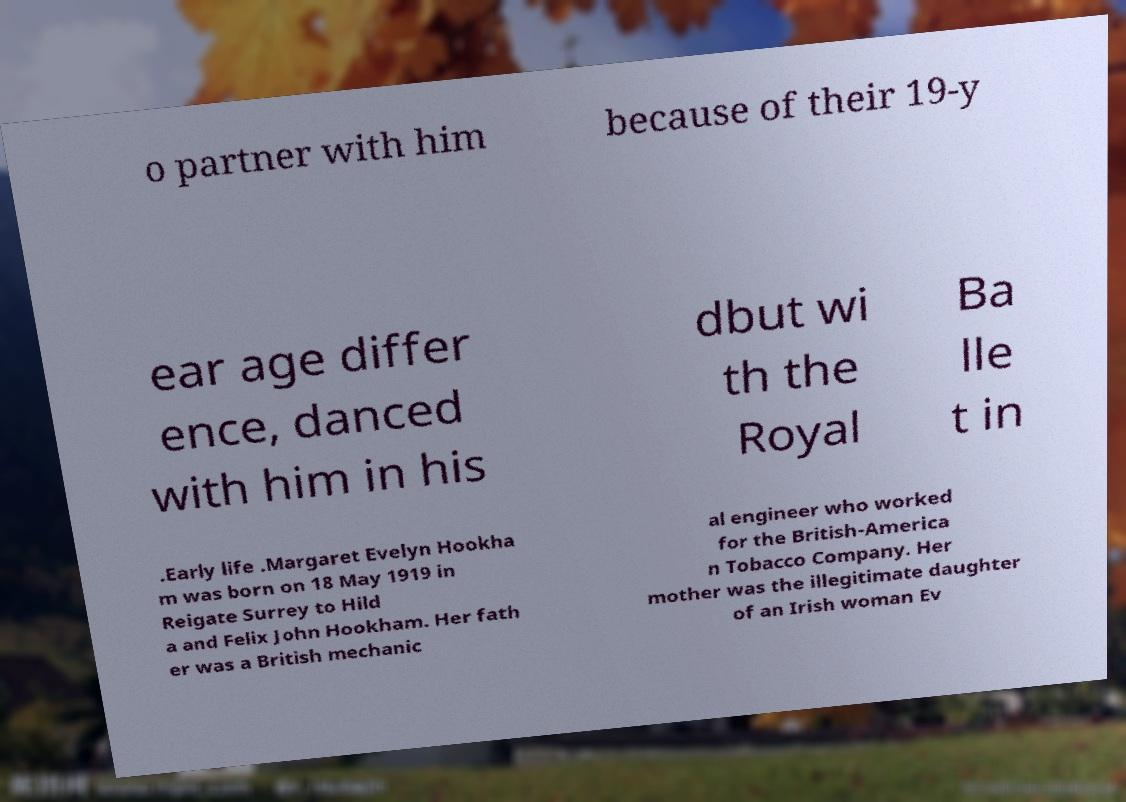Could you extract and type out the text from this image? o partner with him because of their 19-y ear age differ ence, danced with him in his dbut wi th the Royal Ba lle t in .Early life .Margaret Evelyn Hookha m was born on 18 May 1919 in Reigate Surrey to Hild a and Felix John Hookham. Her fath er was a British mechanic al engineer who worked for the British-America n Tobacco Company. Her mother was the illegitimate daughter of an Irish woman Ev 